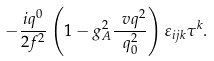<formula> <loc_0><loc_0><loc_500><loc_500>- \frac { i q ^ { 0 } } { 2 f ^ { 2 } } \left ( 1 - g _ { A } ^ { 2 } \frac { \ v q ^ { 2 } } { q _ { 0 } ^ { 2 } } \right ) \varepsilon _ { i j k } \tau ^ { k } .</formula> 